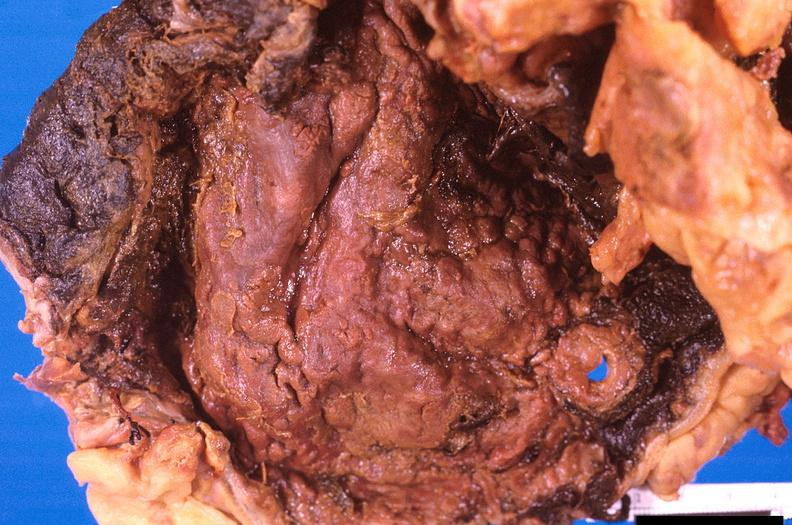what ingested as suicide attempt?
Answer the question using a single word or phrase. Stomach, necrotizing esophagitis and gastritis, sulfuric acid 